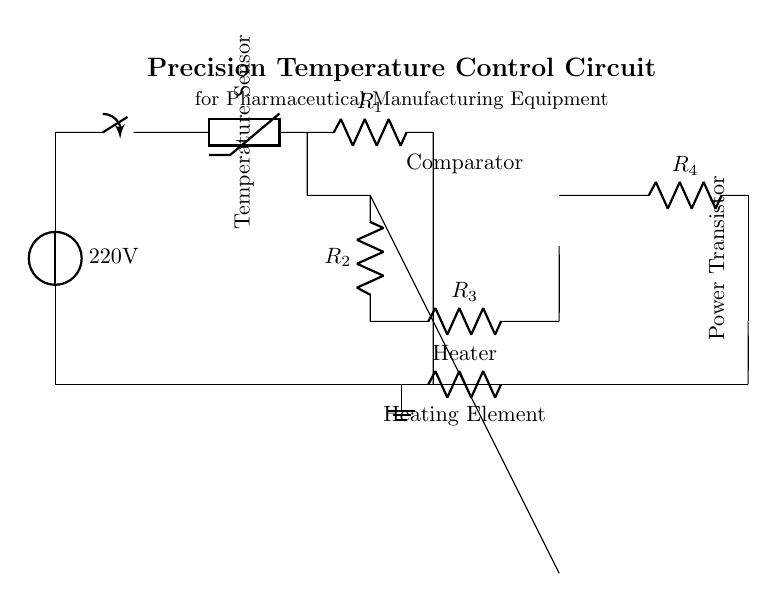What is the voltage source in the circuit? The voltage source is labeled as 220V and is located at the start of the circuit diagram.
Answer: 220V What type of sensor is used in this circuit? The circuit diagram indicates a thermistor is used for temperature measurement, which is a type of temperature sensor.
Answer: Thermistor How many resistors are present in the circuit? There are four resistors labeled as R1, R2, R3, and R4 in the circuit. By counting each of these labeled components, we find a total of four.
Answer: 4 What is the function of the operational amplifier in this circuit? The operational amplifier serves as a comparator, which is used to compare voltages from the temperature sensor and controls the heating element.
Answer: Comparator What component is used to control the heating element? The heating element is controlled by a power transistor, specifically a PNP transistor based on the circuit diagram.
Answer: Power Transistor What indicates the ground point in the circuit? The ground point is denoted by a ground symbol in the circuit diagram, which connects to multiple components to provide a common reference point.
Answer: Ground How is the heating element connected in the circuit? The heating element is connected to the circuit by a resistor marked as "Heater," which serves to include it in the loop alongside other components.
Answer: Resistor 